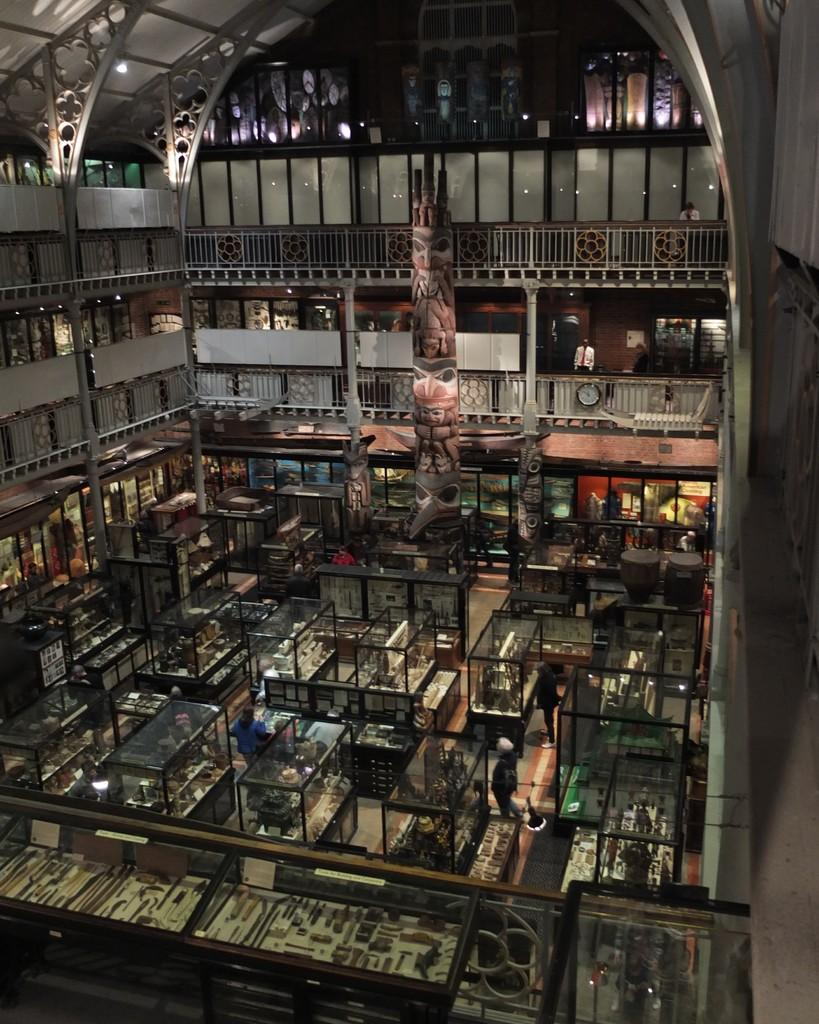What type of location is depicted in the image? The image shows an inside view of a building. How many people are present in the image? There are three persons standing in the image. What are the people wearing? The persons are wearing clothes. What can be seen in the middle of the image? There are glass boxes in the middle of the image. What language are the people speaking in the image? The image does not provide any information about the language being spoken by the people. What is causing friction between the glass boxes in the image? There is no indication of friction between the glass boxes in the image. 